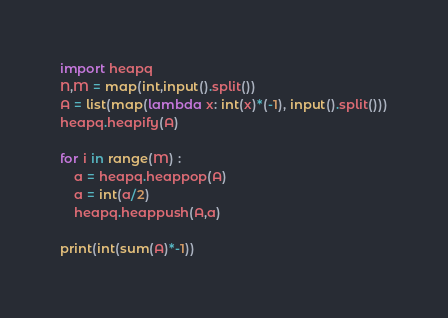<code> <loc_0><loc_0><loc_500><loc_500><_Python_>import heapq
N,M = map(int,input().split())
A = list(map(lambda x: int(x)*(-1), input().split()))
heapq.heapify(A)

for i in range(M) :
    a = heapq.heappop(A)
    a = int(a/2)
    heapq.heappush(A,a)

print(int(sum(A)*-1))</code> 